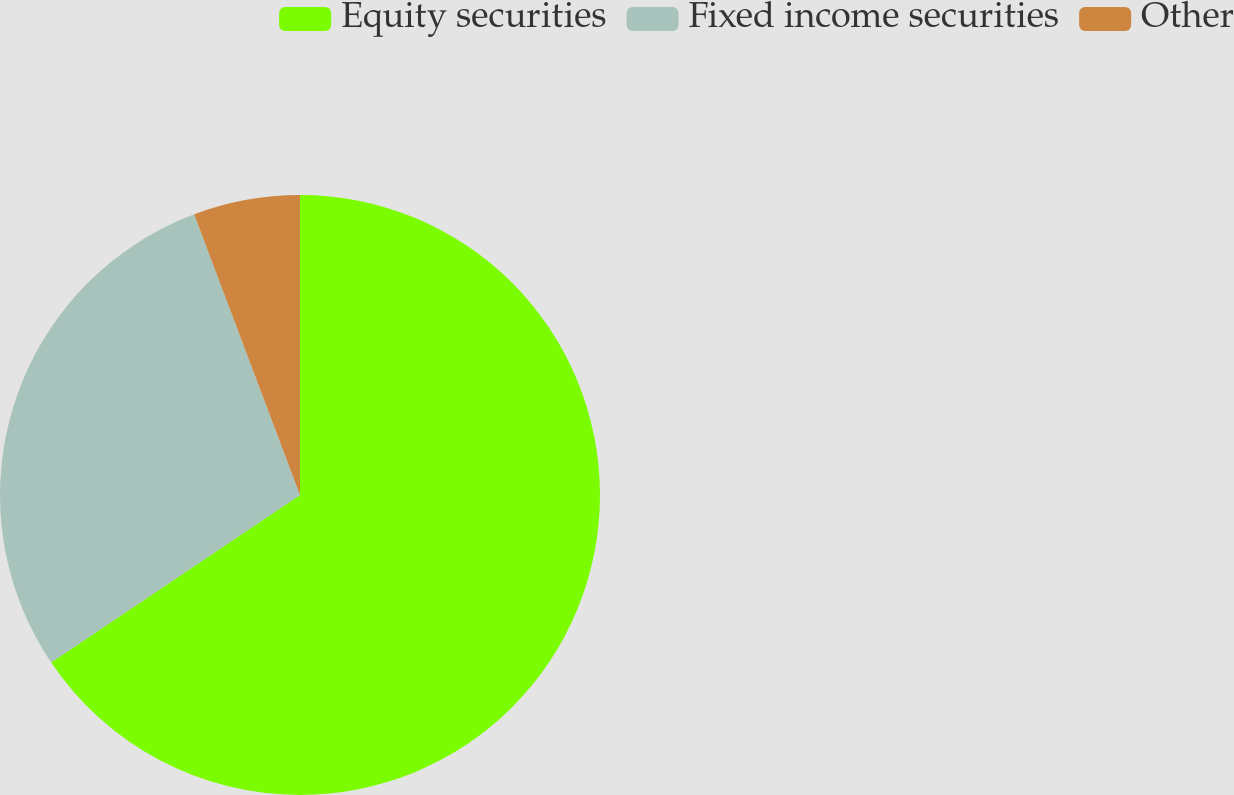Convert chart. <chart><loc_0><loc_0><loc_500><loc_500><pie_chart><fcel>Equity securities<fcel>Fixed income securities<fcel>Other<nl><fcel>65.57%<fcel>28.69%<fcel>5.74%<nl></chart> 